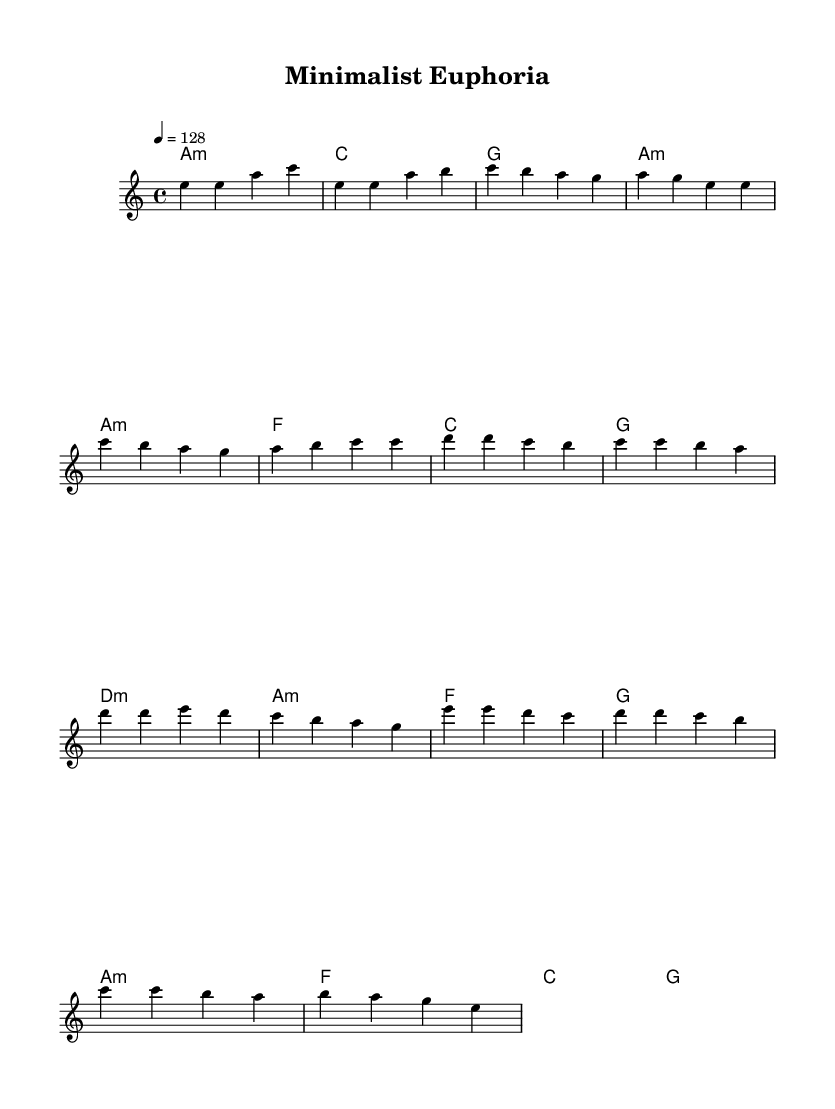What is the key signature of this music? The key signature is A minor, which has no sharps or flats, typically indicating a minor tonality. The notation at the beginning of the sheet music indicates the key signature.
Answer: A minor What is the time signature of this music? The time signature is 4/4, which means there are four beats in each measure and a quarter note gets one beat. This can be seen at the beginning of the piece where the time signature is listed.
Answer: 4/4 What is the tempo marking for this piece? The tempo marking is 128 beats per minute, indicated by the notation "4 = 128" which specifies the speed of the piece.
Answer: 128 How many measures does the chorus section contain? The chorus section contains four measures, as counted from the melody for the chorus. Each distinct grouping in the melody indicates a measure.
Answer: 4 What harmonic structure is used in the pre-chorus? The harmonic structure in the pre-chorus is D minor, A minor, F major, G major. Each chord is aligned with the corresponding notes in the melody, providing the harmonic context for this section.
Answer: D minor, A minor, F major, G major What type of design aesthetic does the song's structure reflect? The song's structure reflects a minimalist design aesthetic characterized by simplicity and repetitive motifs, which is often found in modern K-Pop music. This is evident through the straightforward chord progressions and melodic phrasing.
Answer: Minimalist 